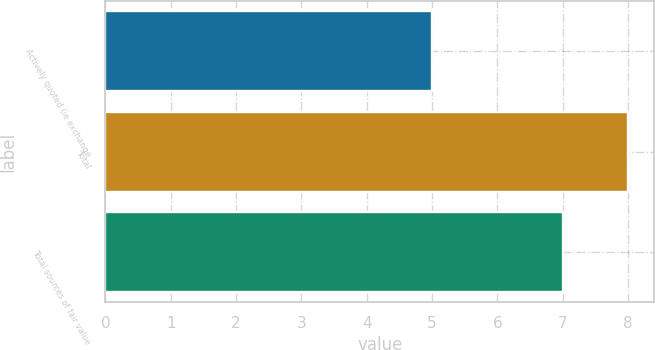Convert chart. <chart><loc_0><loc_0><loc_500><loc_500><bar_chart><fcel>Actively quoted (ie exchange<fcel>Total<fcel>Total sources of fair value<nl><fcel>5<fcel>8<fcel>7<nl></chart> 